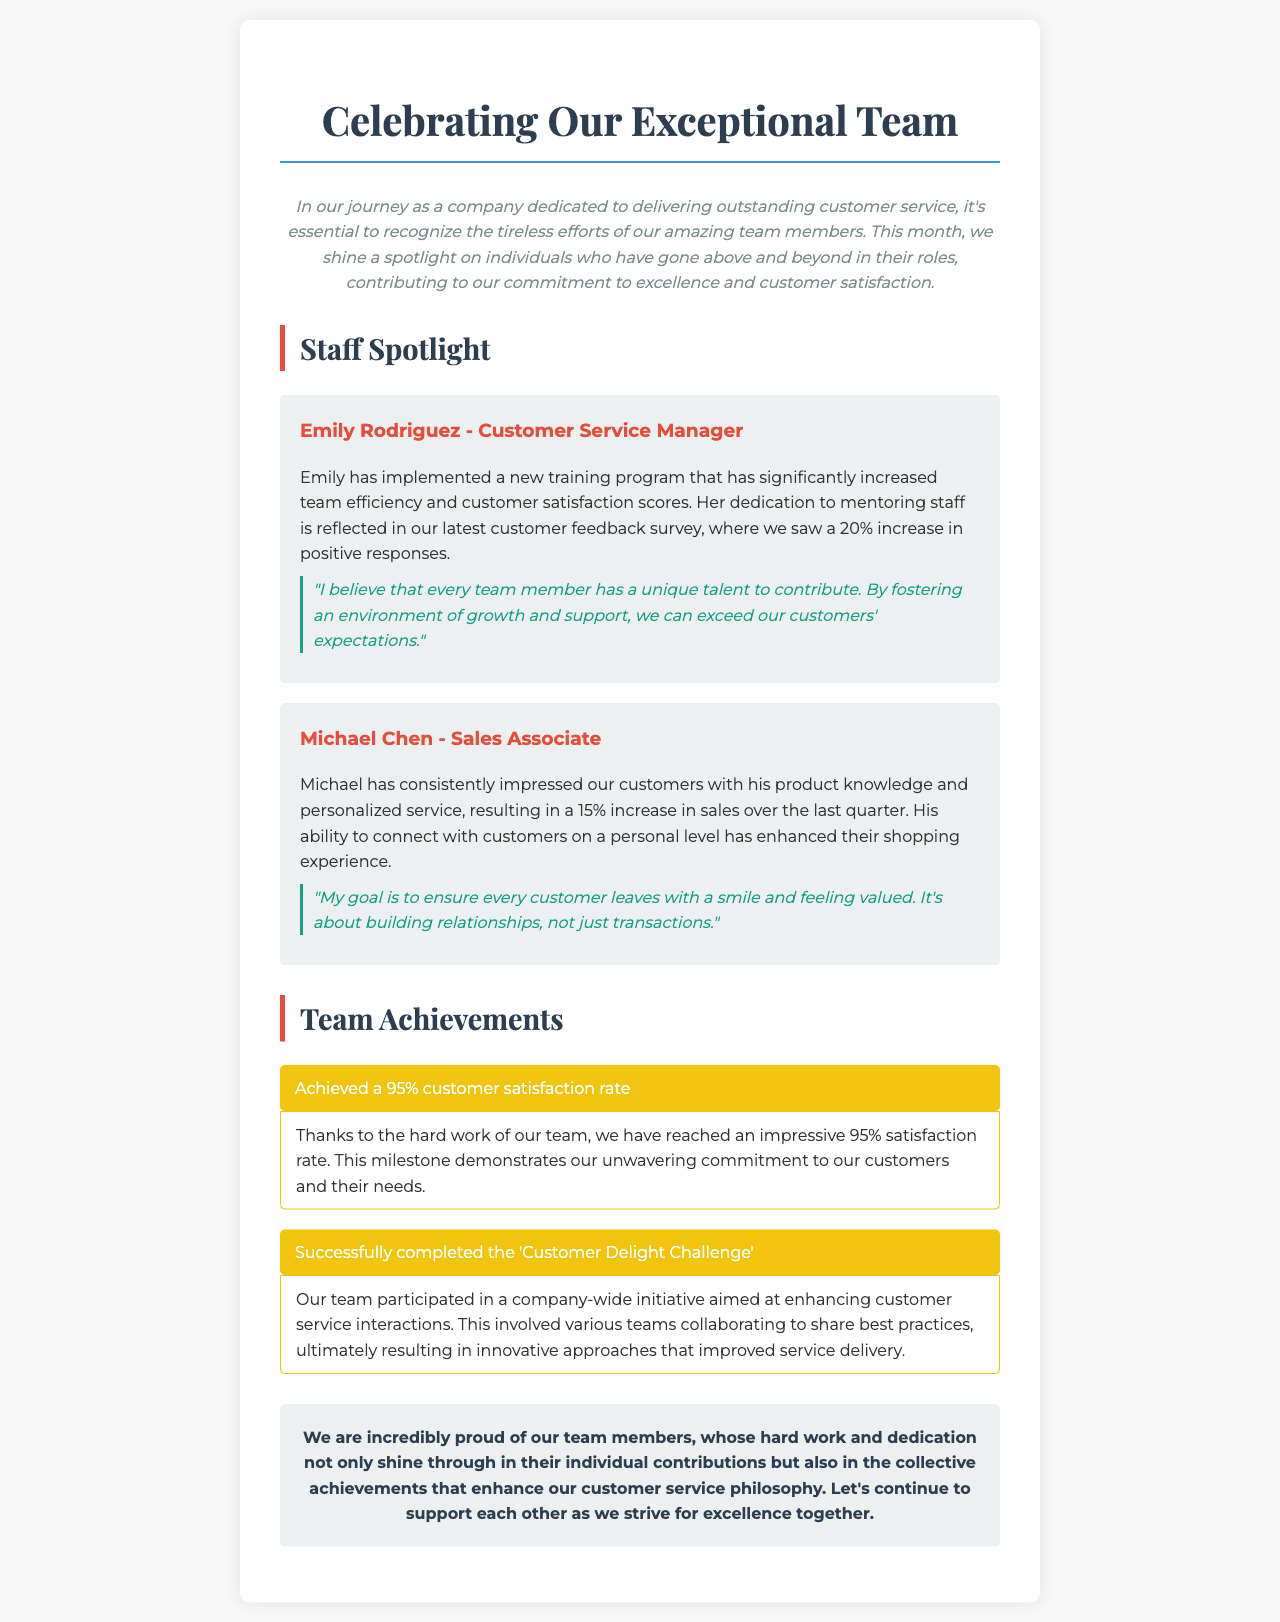What is the title of the newsletter? The title of the newsletter is prominently displayed at the top of the document.
Answer: Celebrating Our Exceptional Team Who is the Customer Service Manager mentioned in the spotlight? The spotlight section identifies each team member by their role and name.
Answer: Emily Rodriguez What percentage increase in positive responses did Emily's training program achieve? The document highlights specific improvements resulting from team efforts, specifically the percentage increase noted.
Answer: 20% What is Michael's role in the company? The document specifies the positions of the team members being featured in the spotlight section.
Answer: Sales Associate What is the customer satisfaction rate achieved by the team? The achievement section explicitly states the customer satisfaction rate attained.
Answer: 95% Which initiative did the team successfully complete? The document outlines team achievements and the specific initiative they participated in.
Answer: Customer Delight Challenge Why does Michael believe customer service is important? Michael's quote provides insight into his philosophy regarding customer service and relationship-building.
Answer: Building relationships What color is used for the achievement background? The document describes the visual style of the achievement section vividly.
Answer: Yellow What type of document is this? The overall layout and content characteristics help identify the nature of the document.
Answer: Newsletter 